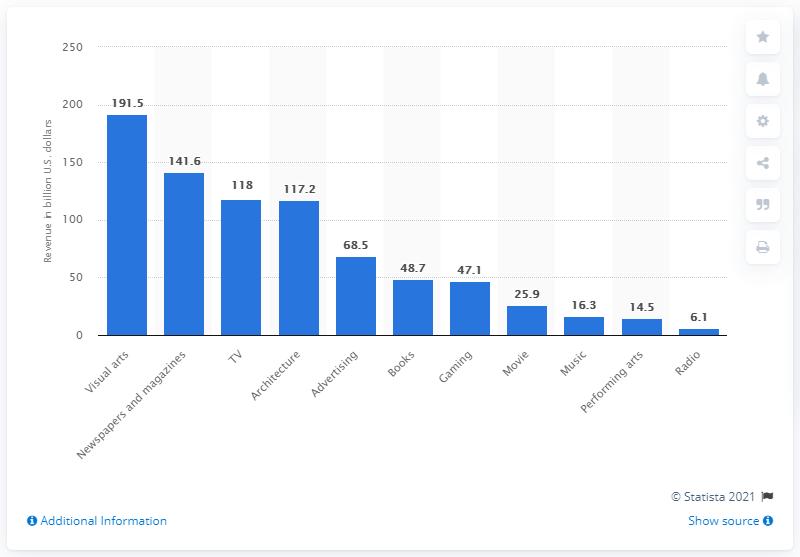Highlight a few significant elements in this photo. In 2013, the Asia Pacific region generated approximately 68.5% of its total revenue from advertising. 